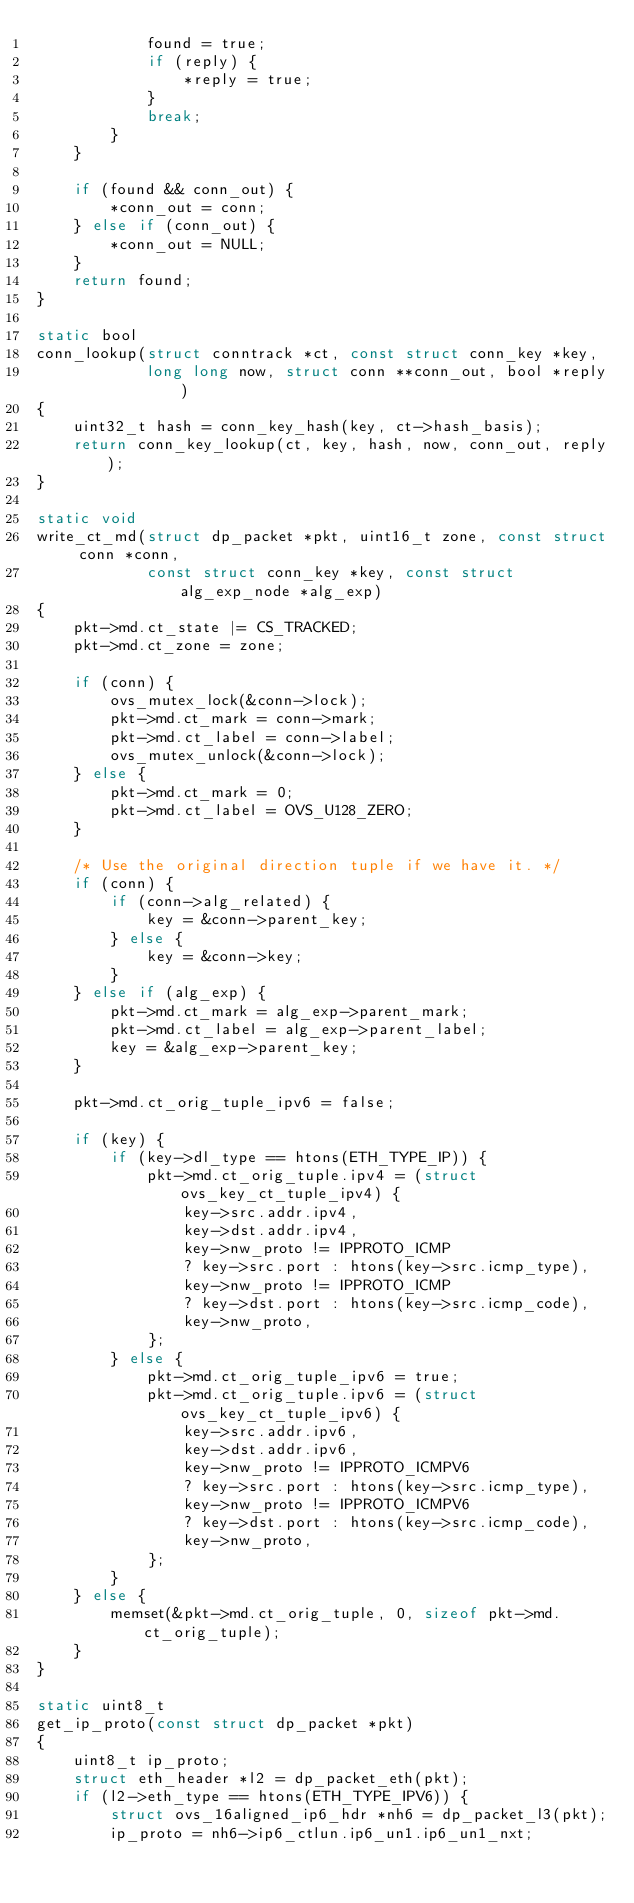Convert code to text. <code><loc_0><loc_0><loc_500><loc_500><_C_>            found = true;
            if (reply) {
                *reply = true;
            }
            break;
        }
    }

    if (found && conn_out) {
        *conn_out = conn;
    } else if (conn_out) {
        *conn_out = NULL;
    }
    return found;
}

static bool
conn_lookup(struct conntrack *ct, const struct conn_key *key,
            long long now, struct conn **conn_out, bool *reply)
{
    uint32_t hash = conn_key_hash(key, ct->hash_basis);
    return conn_key_lookup(ct, key, hash, now, conn_out, reply);
}

static void
write_ct_md(struct dp_packet *pkt, uint16_t zone, const struct conn *conn,
            const struct conn_key *key, const struct alg_exp_node *alg_exp)
{
    pkt->md.ct_state |= CS_TRACKED;
    pkt->md.ct_zone = zone;

    if (conn) {
        ovs_mutex_lock(&conn->lock);
        pkt->md.ct_mark = conn->mark;
        pkt->md.ct_label = conn->label;
        ovs_mutex_unlock(&conn->lock);
    } else {
        pkt->md.ct_mark = 0;
        pkt->md.ct_label = OVS_U128_ZERO;
    }

    /* Use the original direction tuple if we have it. */
    if (conn) {
        if (conn->alg_related) {
            key = &conn->parent_key;
        } else {
            key = &conn->key;
        }
    } else if (alg_exp) {
        pkt->md.ct_mark = alg_exp->parent_mark;
        pkt->md.ct_label = alg_exp->parent_label;
        key = &alg_exp->parent_key;
    }

    pkt->md.ct_orig_tuple_ipv6 = false;

    if (key) {
        if (key->dl_type == htons(ETH_TYPE_IP)) {
            pkt->md.ct_orig_tuple.ipv4 = (struct ovs_key_ct_tuple_ipv4) {
                key->src.addr.ipv4,
                key->dst.addr.ipv4,
                key->nw_proto != IPPROTO_ICMP
                ? key->src.port : htons(key->src.icmp_type),
                key->nw_proto != IPPROTO_ICMP
                ? key->dst.port : htons(key->src.icmp_code),
                key->nw_proto,
            };
        } else {
            pkt->md.ct_orig_tuple_ipv6 = true;
            pkt->md.ct_orig_tuple.ipv6 = (struct ovs_key_ct_tuple_ipv6) {
                key->src.addr.ipv6,
                key->dst.addr.ipv6,
                key->nw_proto != IPPROTO_ICMPV6
                ? key->src.port : htons(key->src.icmp_type),
                key->nw_proto != IPPROTO_ICMPV6
                ? key->dst.port : htons(key->src.icmp_code),
                key->nw_proto,
            };
        }
    } else {
        memset(&pkt->md.ct_orig_tuple, 0, sizeof pkt->md.ct_orig_tuple);
    }
}

static uint8_t
get_ip_proto(const struct dp_packet *pkt)
{
    uint8_t ip_proto;
    struct eth_header *l2 = dp_packet_eth(pkt);
    if (l2->eth_type == htons(ETH_TYPE_IPV6)) {
        struct ovs_16aligned_ip6_hdr *nh6 = dp_packet_l3(pkt);
        ip_proto = nh6->ip6_ctlun.ip6_un1.ip6_un1_nxt;</code> 